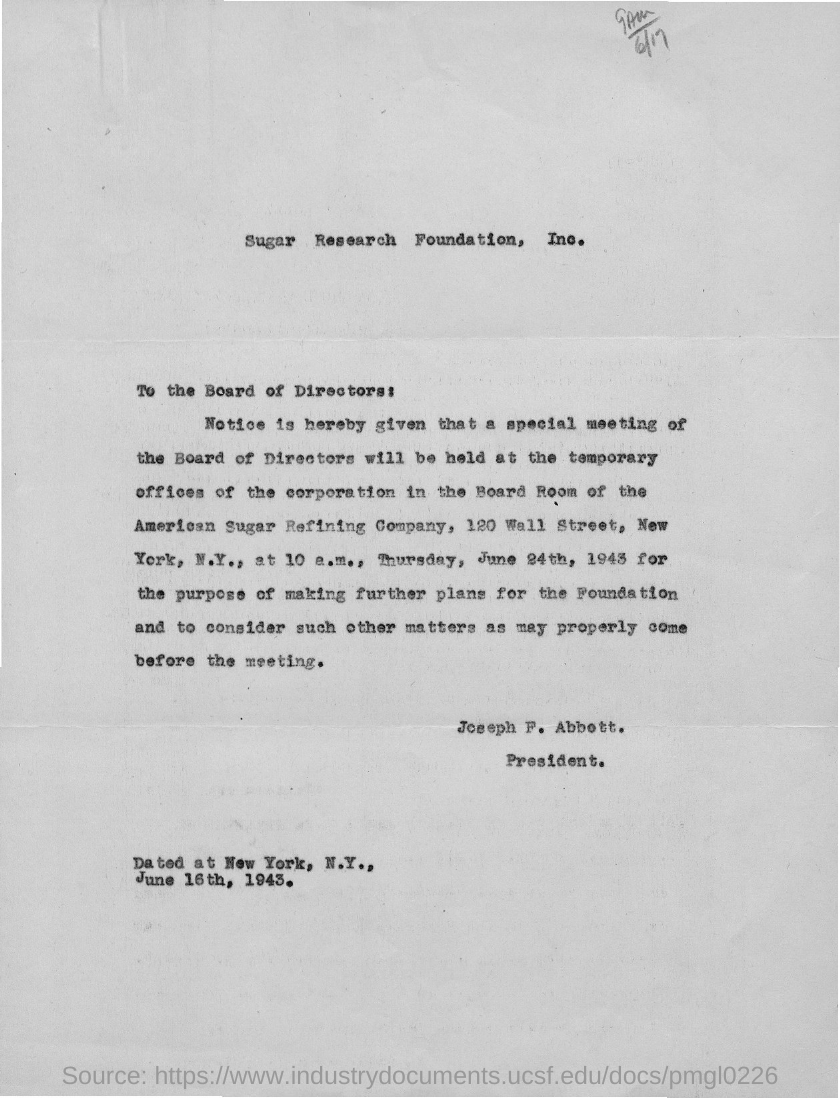Identify some key points in this picture. The document is titled "Sugar Research Foundation, Inc. - Memorandum: Request for Proposals for Research on the Artificial Sweeteners Saccharin, Aspartame, and Sucralose" and it is about a organization called Sugar Research Foundation, Inc. It is known that the current president is Joseph F. Abbott. 